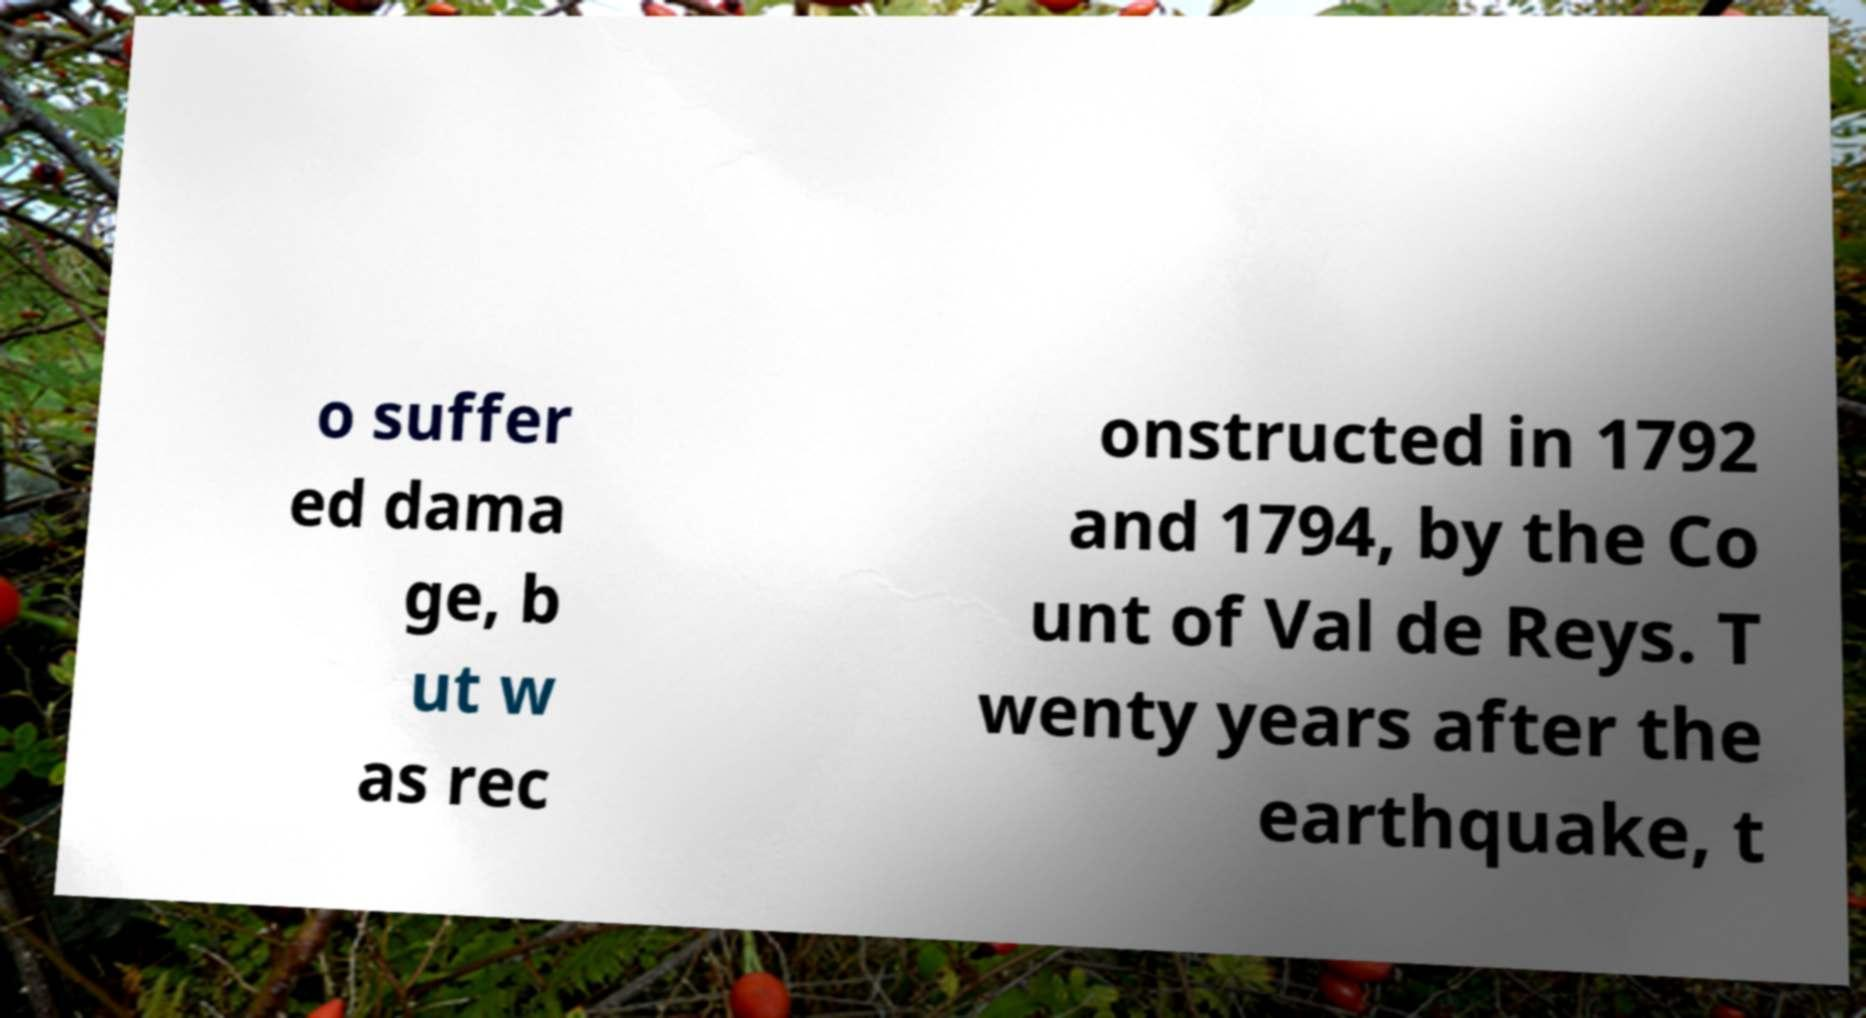Please identify and transcribe the text found in this image. o suffer ed dama ge, b ut w as rec onstructed in 1792 and 1794, by the Co unt of Val de Reys. T wenty years after the earthquake, t 